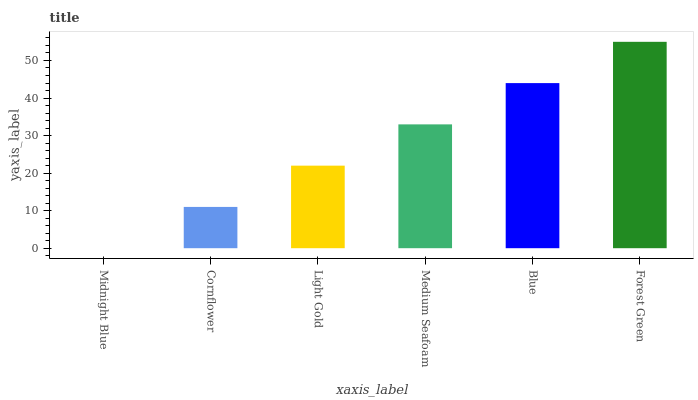Is Midnight Blue the minimum?
Answer yes or no. Yes. Is Forest Green the maximum?
Answer yes or no. Yes. Is Cornflower the minimum?
Answer yes or no. No. Is Cornflower the maximum?
Answer yes or no. No. Is Cornflower greater than Midnight Blue?
Answer yes or no. Yes. Is Midnight Blue less than Cornflower?
Answer yes or no. Yes. Is Midnight Blue greater than Cornflower?
Answer yes or no. No. Is Cornflower less than Midnight Blue?
Answer yes or no. No. Is Medium Seafoam the high median?
Answer yes or no. Yes. Is Light Gold the low median?
Answer yes or no. Yes. Is Blue the high median?
Answer yes or no. No. Is Cornflower the low median?
Answer yes or no. No. 